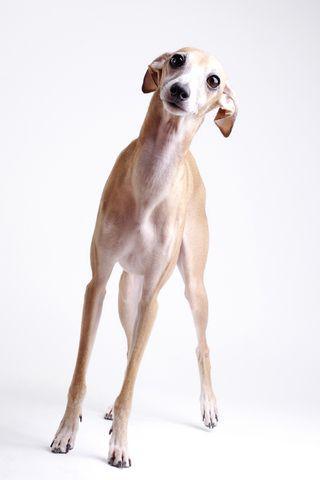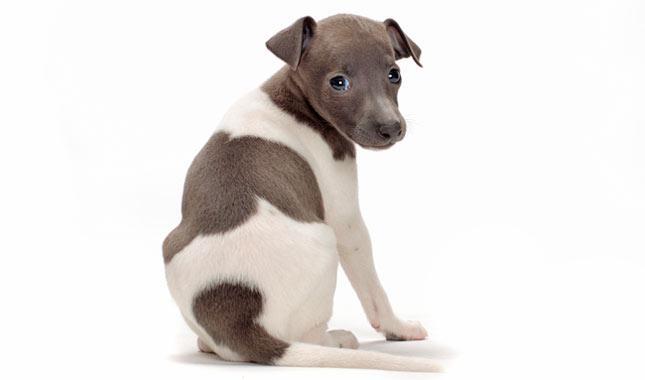The first image is the image on the left, the second image is the image on the right. Considering the images on both sides, is "A dog is curled up next to some type of cushion." valid? Answer yes or no. No. The first image is the image on the left, the second image is the image on the right. Given the left and right images, does the statement "There is at least one dog laying down." hold true? Answer yes or no. No. 